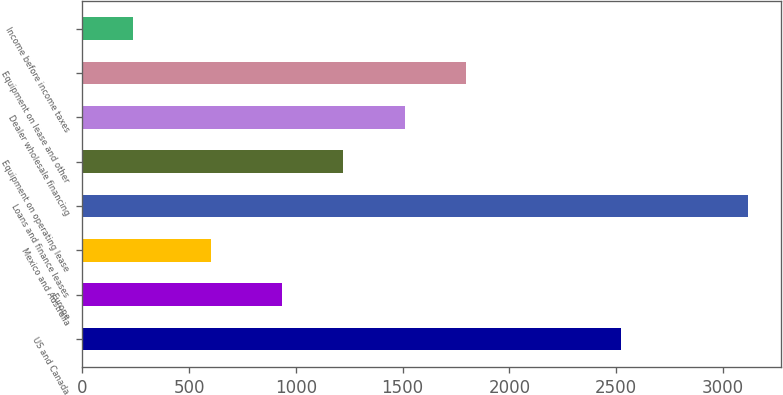Convert chart to OTSL. <chart><loc_0><loc_0><loc_500><loc_500><bar_chart><fcel>US and Canada<fcel>Europe<fcel>Mexico and Australia<fcel>Loans and finance leases<fcel>Equipment on operating lease<fcel>Dealer wholesale financing<fcel>Equipment on lease and other<fcel>Income before income taxes<nl><fcel>2523.1<fcel>933.5<fcel>604.4<fcel>3117.2<fcel>1221.58<fcel>1509.66<fcel>1797.74<fcel>236.4<nl></chart> 